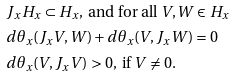Convert formula to latex. <formula><loc_0><loc_0><loc_500><loc_500>& J _ { x } H _ { x } \subset H _ { x } , \text { and for all } V , W \in H _ { x } \\ & d \theta _ { x } ( J _ { x } V , W ) + d \theta _ { x } ( V , J _ { x } W ) = 0 \\ & d \theta _ { x } ( V , J _ { x } V ) > 0 , \text { if } V \neq 0 .</formula> 